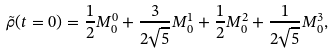Convert formula to latex. <formula><loc_0><loc_0><loc_500><loc_500>\tilde { \rho } ( t = 0 ) = \frac { 1 } { 2 } M ^ { 0 } _ { 0 } + \frac { 3 } { 2 \sqrt { 5 } } M ^ { 1 } _ { 0 } + \frac { 1 } { 2 } M ^ { 2 } _ { 0 } + \frac { 1 } { 2 \sqrt { 5 } } M ^ { 3 } _ { 0 } ,</formula> 